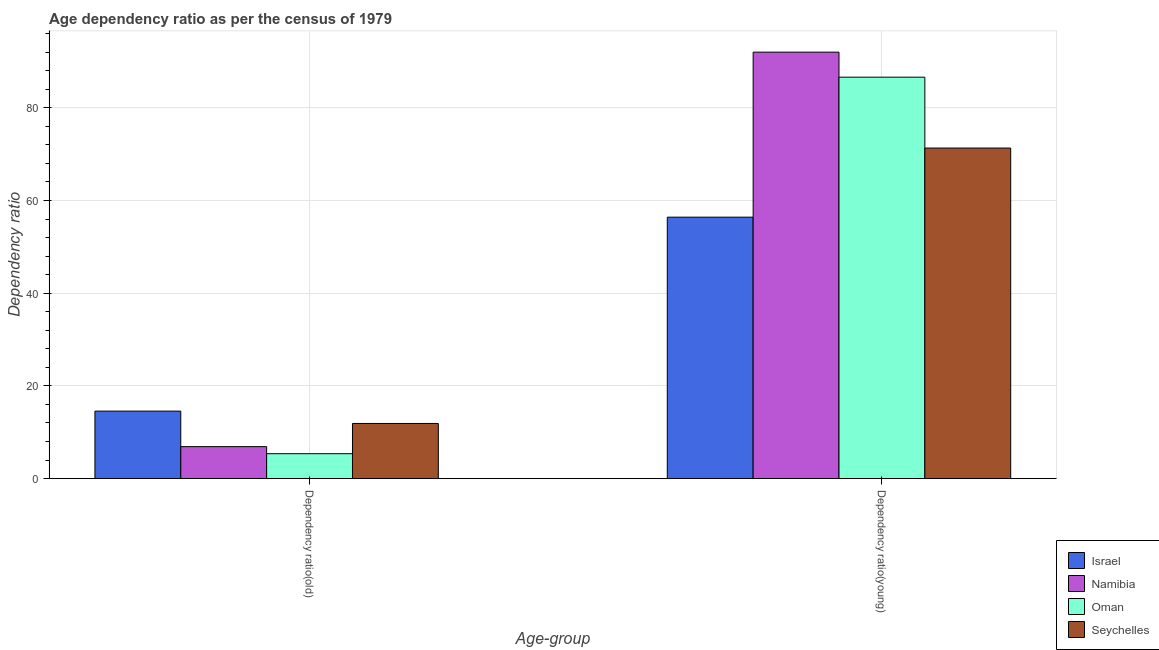Are the number of bars per tick equal to the number of legend labels?
Ensure brevity in your answer.  Yes. Are the number of bars on each tick of the X-axis equal?
Ensure brevity in your answer.  Yes. What is the label of the 2nd group of bars from the left?
Keep it short and to the point. Dependency ratio(young). What is the age dependency ratio(old) in Namibia?
Ensure brevity in your answer.  6.9. Across all countries, what is the maximum age dependency ratio(old)?
Provide a short and direct response. 14.56. Across all countries, what is the minimum age dependency ratio(young)?
Offer a very short reply. 56.41. In which country was the age dependency ratio(young) maximum?
Provide a succinct answer. Namibia. In which country was the age dependency ratio(old) minimum?
Provide a succinct answer. Oman. What is the total age dependency ratio(old) in the graph?
Offer a terse response. 38.74. What is the difference between the age dependency ratio(old) in Namibia and that in Israel?
Your answer should be very brief. -7.66. What is the difference between the age dependency ratio(old) in Namibia and the age dependency ratio(young) in Israel?
Offer a very short reply. -49.51. What is the average age dependency ratio(old) per country?
Keep it short and to the point. 9.68. What is the difference between the age dependency ratio(young) and age dependency ratio(old) in Israel?
Make the answer very short. 41.85. What is the ratio of the age dependency ratio(young) in Israel to that in Namibia?
Your response must be concise. 0.61. In how many countries, is the age dependency ratio(young) greater than the average age dependency ratio(young) taken over all countries?
Provide a short and direct response. 2. What does the 4th bar from the left in Dependency ratio(old) represents?
Offer a very short reply. Seychelles. What does the 2nd bar from the right in Dependency ratio(old) represents?
Ensure brevity in your answer.  Oman. How many bars are there?
Provide a succinct answer. 8. How many countries are there in the graph?
Offer a terse response. 4. Are the values on the major ticks of Y-axis written in scientific E-notation?
Your response must be concise. No. Where does the legend appear in the graph?
Keep it short and to the point. Bottom right. What is the title of the graph?
Your answer should be very brief. Age dependency ratio as per the census of 1979. What is the label or title of the X-axis?
Offer a terse response. Age-group. What is the label or title of the Y-axis?
Provide a short and direct response. Dependency ratio. What is the Dependency ratio of Israel in Dependency ratio(old)?
Your answer should be compact. 14.56. What is the Dependency ratio of Namibia in Dependency ratio(old)?
Your answer should be compact. 6.9. What is the Dependency ratio in Oman in Dependency ratio(old)?
Provide a succinct answer. 5.38. What is the Dependency ratio in Seychelles in Dependency ratio(old)?
Make the answer very short. 11.9. What is the Dependency ratio in Israel in Dependency ratio(young)?
Your answer should be very brief. 56.41. What is the Dependency ratio in Namibia in Dependency ratio(young)?
Your answer should be very brief. 92.01. What is the Dependency ratio of Oman in Dependency ratio(young)?
Make the answer very short. 86.61. What is the Dependency ratio in Seychelles in Dependency ratio(young)?
Make the answer very short. 71.32. Across all Age-group, what is the maximum Dependency ratio of Israel?
Your answer should be compact. 56.41. Across all Age-group, what is the maximum Dependency ratio of Namibia?
Your answer should be compact. 92.01. Across all Age-group, what is the maximum Dependency ratio of Oman?
Keep it short and to the point. 86.61. Across all Age-group, what is the maximum Dependency ratio in Seychelles?
Ensure brevity in your answer.  71.32. Across all Age-group, what is the minimum Dependency ratio of Israel?
Make the answer very short. 14.56. Across all Age-group, what is the minimum Dependency ratio of Namibia?
Provide a succinct answer. 6.9. Across all Age-group, what is the minimum Dependency ratio in Oman?
Your answer should be compact. 5.38. Across all Age-group, what is the minimum Dependency ratio in Seychelles?
Give a very brief answer. 11.9. What is the total Dependency ratio in Israel in the graph?
Provide a succinct answer. 70.97. What is the total Dependency ratio of Namibia in the graph?
Offer a terse response. 98.91. What is the total Dependency ratio in Oman in the graph?
Keep it short and to the point. 91.99. What is the total Dependency ratio of Seychelles in the graph?
Your answer should be compact. 83.22. What is the difference between the Dependency ratio in Israel in Dependency ratio(old) and that in Dependency ratio(young)?
Make the answer very short. -41.85. What is the difference between the Dependency ratio in Namibia in Dependency ratio(old) and that in Dependency ratio(young)?
Keep it short and to the point. -85.11. What is the difference between the Dependency ratio of Oman in Dependency ratio(old) and that in Dependency ratio(young)?
Give a very brief answer. -81.24. What is the difference between the Dependency ratio in Seychelles in Dependency ratio(old) and that in Dependency ratio(young)?
Offer a very short reply. -59.42. What is the difference between the Dependency ratio in Israel in Dependency ratio(old) and the Dependency ratio in Namibia in Dependency ratio(young)?
Provide a succinct answer. -77.45. What is the difference between the Dependency ratio of Israel in Dependency ratio(old) and the Dependency ratio of Oman in Dependency ratio(young)?
Your answer should be compact. -72.05. What is the difference between the Dependency ratio in Israel in Dependency ratio(old) and the Dependency ratio in Seychelles in Dependency ratio(young)?
Keep it short and to the point. -56.76. What is the difference between the Dependency ratio of Namibia in Dependency ratio(old) and the Dependency ratio of Oman in Dependency ratio(young)?
Your answer should be very brief. -79.71. What is the difference between the Dependency ratio in Namibia in Dependency ratio(old) and the Dependency ratio in Seychelles in Dependency ratio(young)?
Ensure brevity in your answer.  -64.42. What is the difference between the Dependency ratio in Oman in Dependency ratio(old) and the Dependency ratio in Seychelles in Dependency ratio(young)?
Offer a very short reply. -65.95. What is the average Dependency ratio in Israel per Age-group?
Your response must be concise. 35.49. What is the average Dependency ratio in Namibia per Age-group?
Provide a short and direct response. 49.46. What is the average Dependency ratio in Oman per Age-group?
Provide a short and direct response. 45.99. What is the average Dependency ratio in Seychelles per Age-group?
Your answer should be very brief. 41.61. What is the difference between the Dependency ratio of Israel and Dependency ratio of Namibia in Dependency ratio(old)?
Keep it short and to the point. 7.66. What is the difference between the Dependency ratio of Israel and Dependency ratio of Oman in Dependency ratio(old)?
Offer a terse response. 9.19. What is the difference between the Dependency ratio in Israel and Dependency ratio in Seychelles in Dependency ratio(old)?
Your answer should be compact. 2.66. What is the difference between the Dependency ratio in Namibia and Dependency ratio in Oman in Dependency ratio(old)?
Your answer should be very brief. 1.52. What is the difference between the Dependency ratio in Namibia and Dependency ratio in Seychelles in Dependency ratio(old)?
Provide a short and direct response. -5. What is the difference between the Dependency ratio of Oman and Dependency ratio of Seychelles in Dependency ratio(old)?
Your answer should be very brief. -6.52. What is the difference between the Dependency ratio of Israel and Dependency ratio of Namibia in Dependency ratio(young)?
Your answer should be very brief. -35.6. What is the difference between the Dependency ratio of Israel and Dependency ratio of Oman in Dependency ratio(young)?
Your response must be concise. -30.2. What is the difference between the Dependency ratio in Israel and Dependency ratio in Seychelles in Dependency ratio(young)?
Provide a succinct answer. -14.91. What is the difference between the Dependency ratio in Namibia and Dependency ratio in Oman in Dependency ratio(young)?
Your answer should be compact. 5.4. What is the difference between the Dependency ratio in Namibia and Dependency ratio in Seychelles in Dependency ratio(young)?
Provide a succinct answer. 20.69. What is the difference between the Dependency ratio in Oman and Dependency ratio in Seychelles in Dependency ratio(young)?
Provide a short and direct response. 15.29. What is the ratio of the Dependency ratio of Israel in Dependency ratio(old) to that in Dependency ratio(young)?
Your answer should be very brief. 0.26. What is the ratio of the Dependency ratio in Namibia in Dependency ratio(old) to that in Dependency ratio(young)?
Your answer should be very brief. 0.07. What is the ratio of the Dependency ratio in Oman in Dependency ratio(old) to that in Dependency ratio(young)?
Your answer should be very brief. 0.06. What is the ratio of the Dependency ratio in Seychelles in Dependency ratio(old) to that in Dependency ratio(young)?
Your response must be concise. 0.17. What is the difference between the highest and the second highest Dependency ratio of Israel?
Your answer should be compact. 41.85. What is the difference between the highest and the second highest Dependency ratio in Namibia?
Ensure brevity in your answer.  85.11. What is the difference between the highest and the second highest Dependency ratio in Oman?
Ensure brevity in your answer.  81.24. What is the difference between the highest and the second highest Dependency ratio of Seychelles?
Ensure brevity in your answer.  59.42. What is the difference between the highest and the lowest Dependency ratio in Israel?
Keep it short and to the point. 41.85. What is the difference between the highest and the lowest Dependency ratio in Namibia?
Offer a very short reply. 85.11. What is the difference between the highest and the lowest Dependency ratio of Oman?
Provide a short and direct response. 81.24. What is the difference between the highest and the lowest Dependency ratio in Seychelles?
Offer a very short reply. 59.42. 